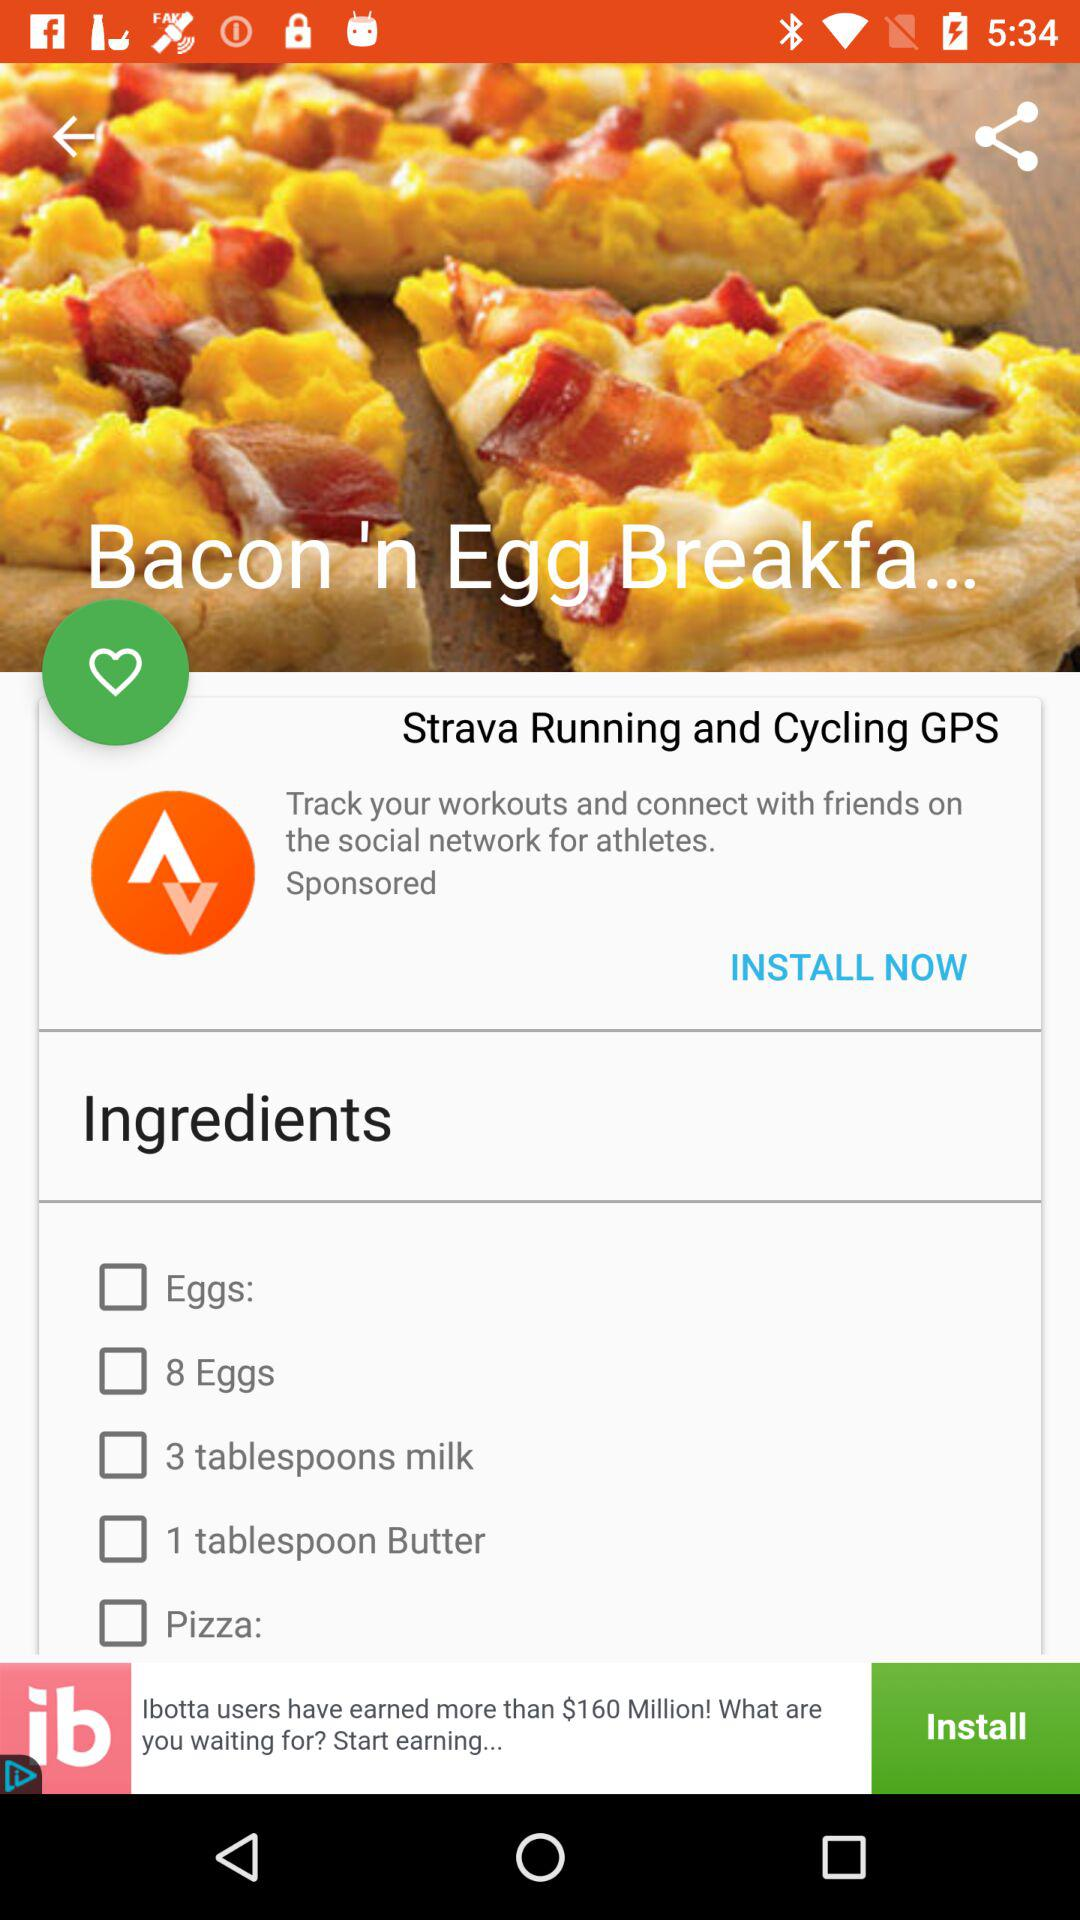How many eggs do you need for this recipe?
Answer the question using a single word or phrase. 8 